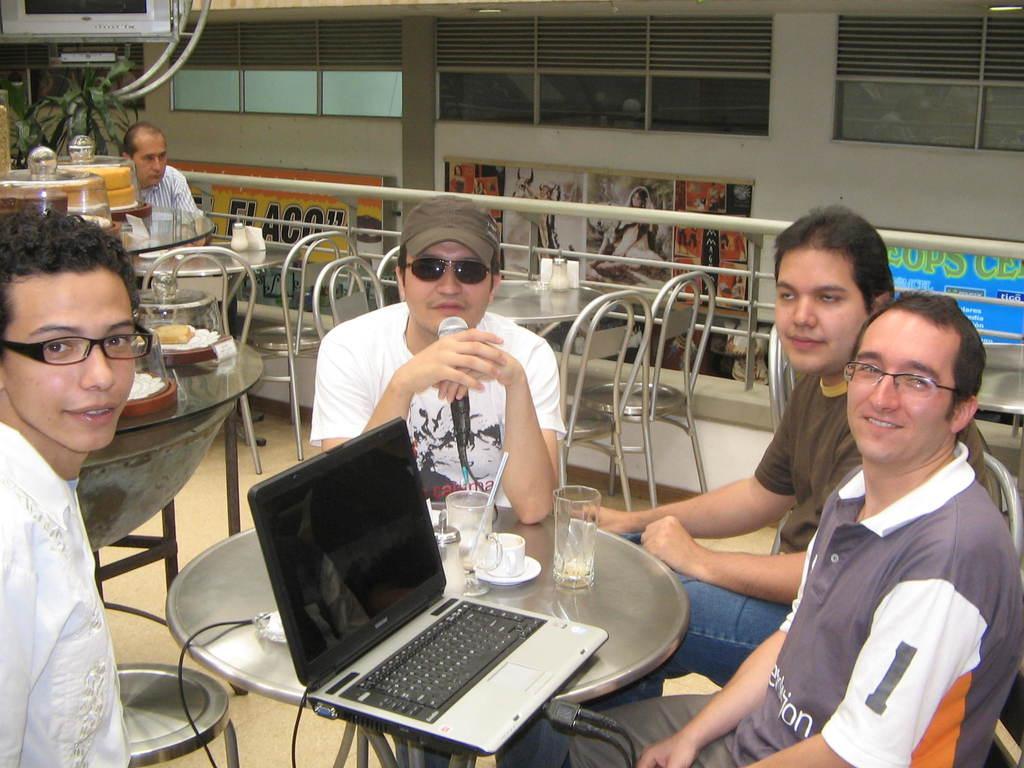How would you summarize this image in a sentence or two? People are sitting on chairs. In-front of them there are tables, on these tables there are glasses, jars, cup, saucer and laptop. Here we can see a television and plants. These are hoarding on wall and glass windows. This man wore goggles and holding a mic. 